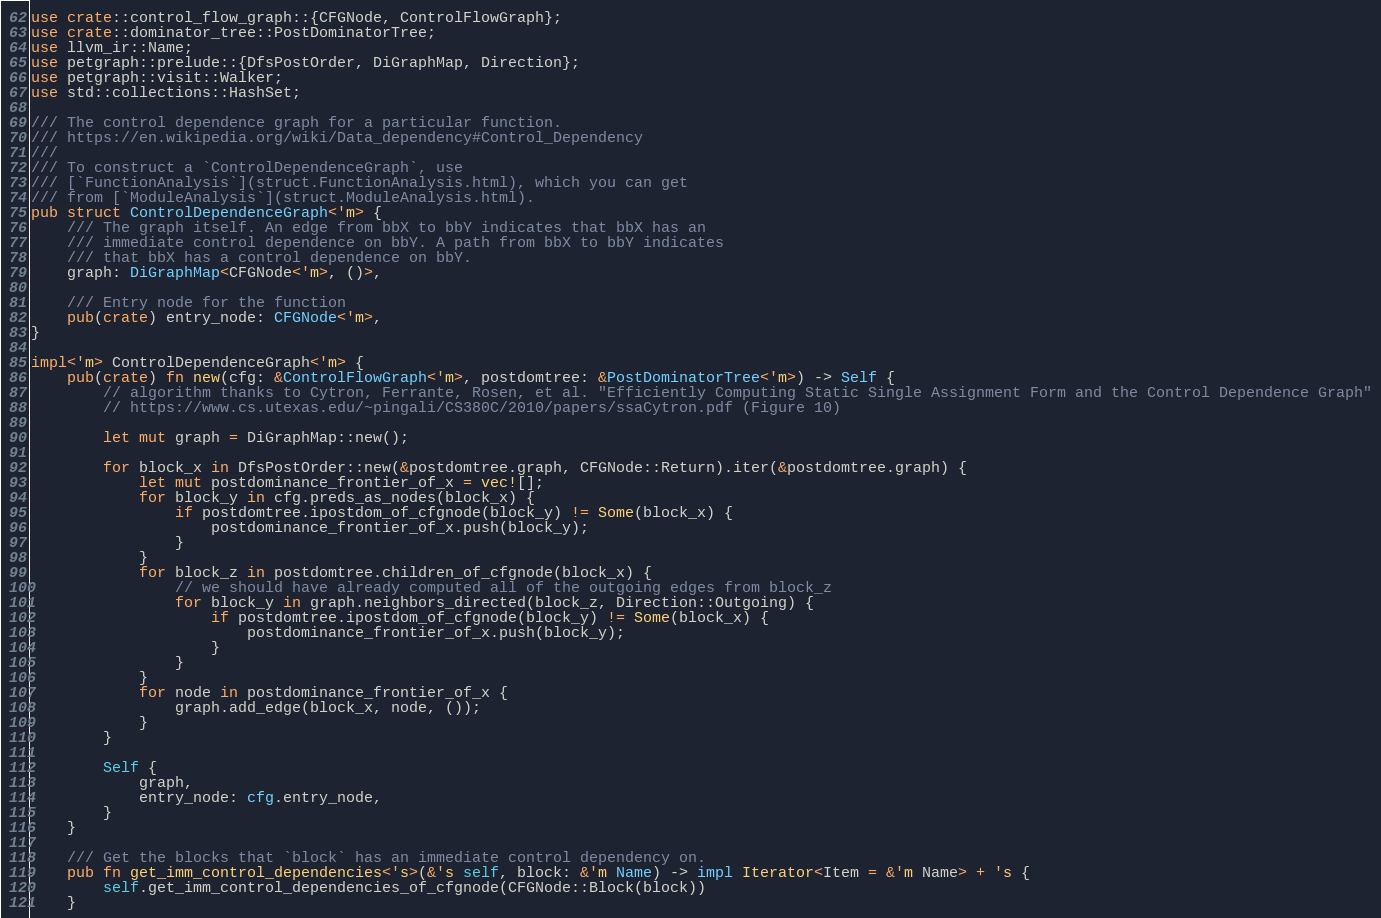<code> <loc_0><loc_0><loc_500><loc_500><_Rust_>use crate::control_flow_graph::{CFGNode, ControlFlowGraph};
use crate::dominator_tree::PostDominatorTree;
use llvm_ir::Name;
use petgraph::prelude::{DfsPostOrder, DiGraphMap, Direction};
use petgraph::visit::Walker;
use std::collections::HashSet;

/// The control dependence graph for a particular function.
/// https://en.wikipedia.org/wiki/Data_dependency#Control_Dependency
///
/// To construct a `ControlDependenceGraph`, use
/// [`FunctionAnalysis`](struct.FunctionAnalysis.html), which you can get
/// from [`ModuleAnalysis`](struct.ModuleAnalysis.html).
pub struct ControlDependenceGraph<'m> {
    /// The graph itself. An edge from bbX to bbY indicates that bbX has an
    /// immediate control dependence on bbY. A path from bbX to bbY indicates
    /// that bbX has a control dependence on bbY.
    graph: DiGraphMap<CFGNode<'m>, ()>,

    /// Entry node for the function
    pub(crate) entry_node: CFGNode<'m>,
}

impl<'m> ControlDependenceGraph<'m> {
    pub(crate) fn new(cfg: &ControlFlowGraph<'m>, postdomtree: &PostDominatorTree<'m>) -> Self {
        // algorithm thanks to Cytron, Ferrante, Rosen, et al. "Efficiently Computing Static Single Assignment Form and the Control Dependence Graph"
        // https://www.cs.utexas.edu/~pingali/CS380C/2010/papers/ssaCytron.pdf (Figure 10)

        let mut graph = DiGraphMap::new();

        for block_x in DfsPostOrder::new(&postdomtree.graph, CFGNode::Return).iter(&postdomtree.graph) {
            let mut postdominance_frontier_of_x = vec![];
            for block_y in cfg.preds_as_nodes(block_x) {
                if postdomtree.ipostdom_of_cfgnode(block_y) != Some(block_x) {
                    postdominance_frontier_of_x.push(block_y);
                }
            }
            for block_z in postdomtree.children_of_cfgnode(block_x) {
                // we should have already computed all of the outgoing edges from block_z
                for block_y in graph.neighbors_directed(block_z, Direction::Outgoing) {
                    if postdomtree.ipostdom_of_cfgnode(block_y) != Some(block_x) {
                        postdominance_frontier_of_x.push(block_y);
                    }
                }
            }
            for node in postdominance_frontier_of_x {
                graph.add_edge(block_x, node, ());
            }
        }

        Self {
            graph,
            entry_node: cfg.entry_node,
        }
    }

    /// Get the blocks that `block` has an immediate control dependency on.
    pub fn get_imm_control_dependencies<'s>(&'s self, block: &'m Name) -> impl Iterator<Item = &'m Name> + 's {
        self.get_imm_control_dependencies_of_cfgnode(CFGNode::Block(block))
    }
</code> 